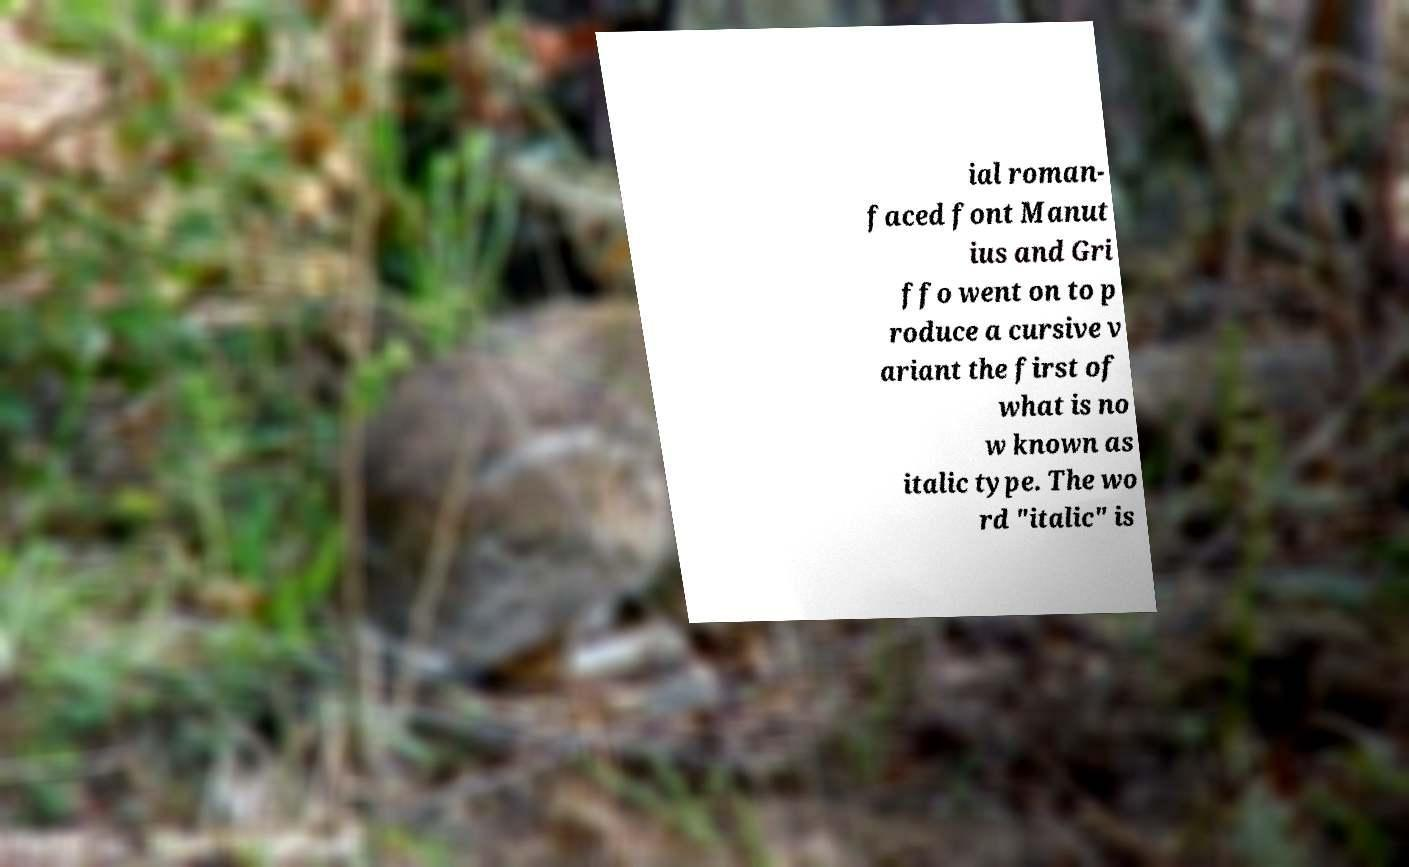For documentation purposes, I need the text within this image transcribed. Could you provide that? ial roman- faced font Manut ius and Gri ffo went on to p roduce a cursive v ariant the first of what is no w known as italic type. The wo rd "italic" is 